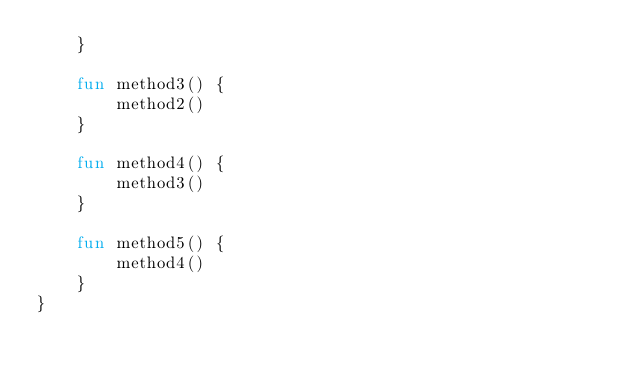<code> <loc_0><loc_0><loc_500><loc_500><_Kotlin_>    }

    fun method3() {
        method2()
    }

    fun method4() {
        method3()
    }

    fun method5() {
        method4()
    }
}
</code> 